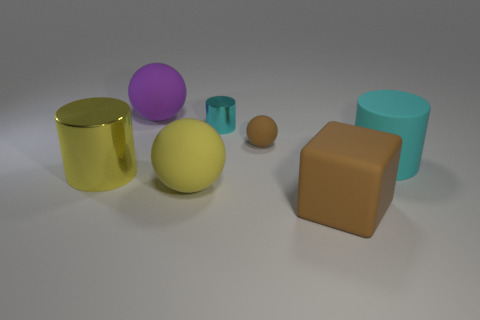Can you describe the different objects and their colors in this image? Certainly! The image features a collection of geometric shapes in a variety of colors. There's a large yellow cylinder, a large cyan cylinder, and a smaller teal-colored cylinder. Additionally, there's a large purple sphere, a medium-sized yellow sphere, and a small brown sphere. Completing the set, we see a large brown cube. 